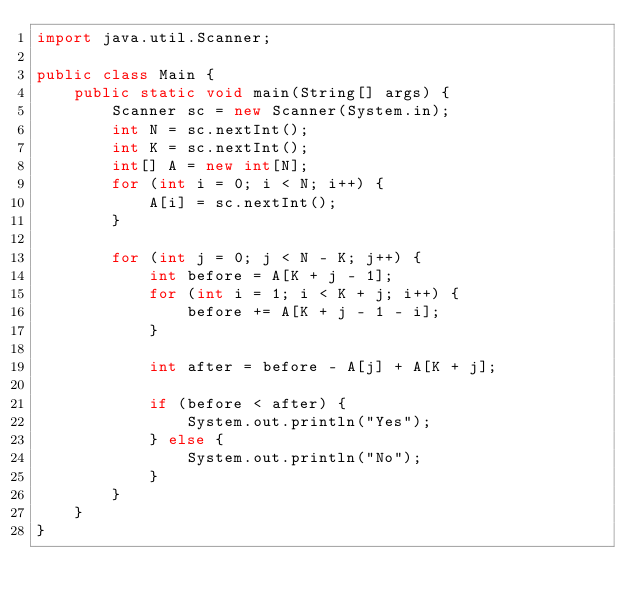Convert code to text. <code><loc_0><loc_0><loc_500><loc_500><_Java_>import java.util.Scanner;

public class Main {
    public static void main(String[] args) {
        Scanner sc = new Scanner(System.in);
        int N = sc.nextInt();
        int K = sc.nextInt();
        int[] A = new int[N];
        for (int i = 0; i < N; i++) {
            A[i] = sc.nextInt();
        }

        for (int j = 0; j < N - K; j++) {
            int before = A[K + j - 1];
            for (int i = 1; i < K + j; i++) {
                before += A[K + j - 1 - i];
            }

            int after = before - A[j] + A[K + j];

            if (before < after) {
                System.out.println("Yes");
            } else {
                System.out.println("No");
            }
        }
    }
}
</code> 